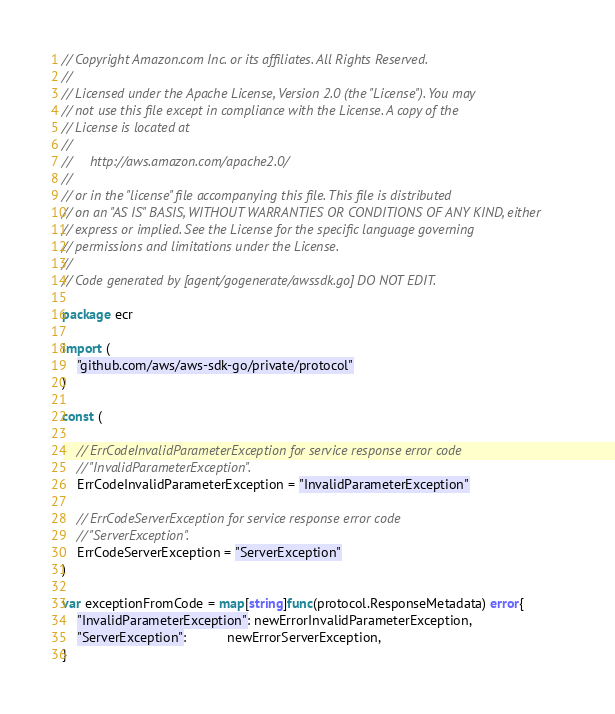Convert code to text. <code><loc_0><loc_0><loc_500><loc_500><_Go_>// Copyright Amazon.com Inc. or its affiliates. All Rights Reserved.
//
// Licensed under the Apache License, Version 2.0 (the "License"). You may
// not use this file except in compliance with the License. A copy of the
// License is located at
//
//     http://aws.amazon.com/apache2.0/
//
// or in the "license" file accompanying this file. This file is distributed
// on an "AS IS" BASIS, WITHOUT WARRANTIES OR CONDITIONS OF ANY KIND, either
// express or implied. See the License for the specific language governing
// permissions and limitations under the License.
//
// Code generated by [agent/gogenerate/awssdk.go] DO NOT EDIT.

package ecr

import (
	"github.com/aws/aws-sdk-go/private/protocol"
)

const (

	// ErrCodeInvalidParameterException for service response error code
	// "InvalidParameterException".
	ErrCodeInvalidParameterException = "InvalidParameterException"

	// ErrCodeServerException for service response error code
	// "ServerException".
	ErrCodeServerException = "ServerException"
)

var exceptionFromCode = map[string]func(protocol.ResponseMetadata) error{
	"InvalidParameterException": newErrorInvalidParameterException,
	"ServerException":           newErrorServerException,
}
</code> 